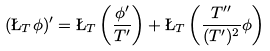Convert formula to latex. <formula><loc_0><loc_0><loc_500><loc_500>( \L _ { T } \phi ) ^ { \prime } = \L _ { T } \left ( \frac { \phi ^ { \prime } } { T ^ { \prime } } \right ) + \L _ { T } \left ( \frac { T ^ { \prime \prime } } { ( T ^ { \prime } ) ^ { 2 } } \phi \right )</formula> 